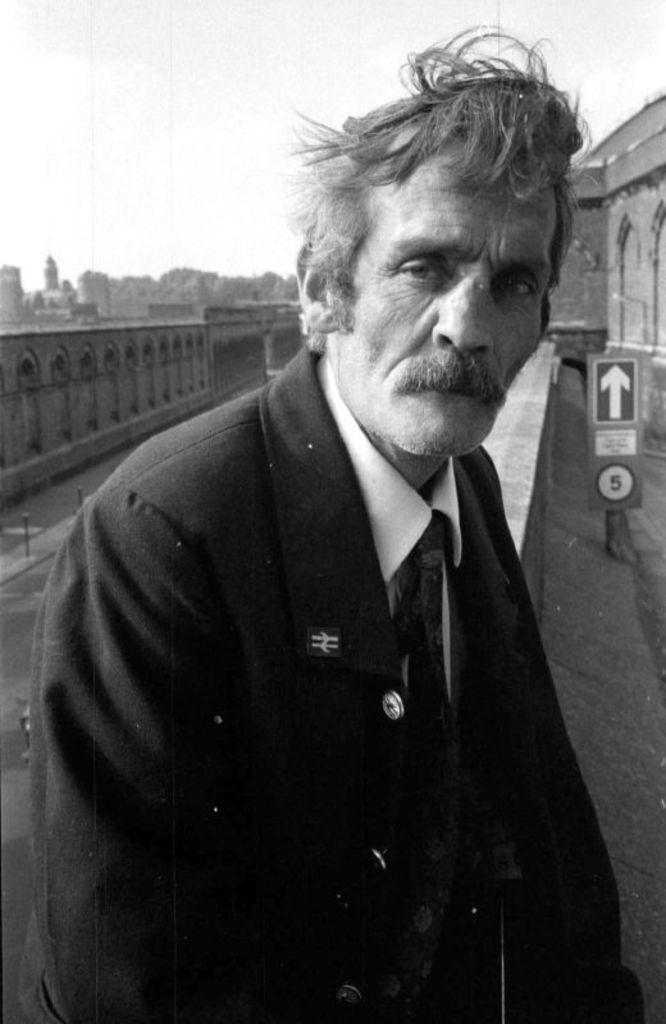Can you describe this image briefly? In this image we can see a man is sitting, he is wearing the suit, at back here is the building, here it is in black and white, at above here is the sky. 